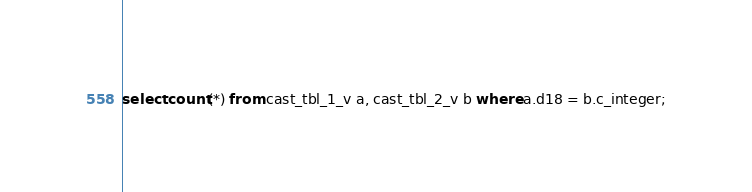Convert code to text. <code><loc_0><loc_0><loc_500><loc_500><_SQL_>select count(*) from cast_tbl_1_v a, cast_tbl_2_v b where a.d18 = b.c_integer;
</code> 